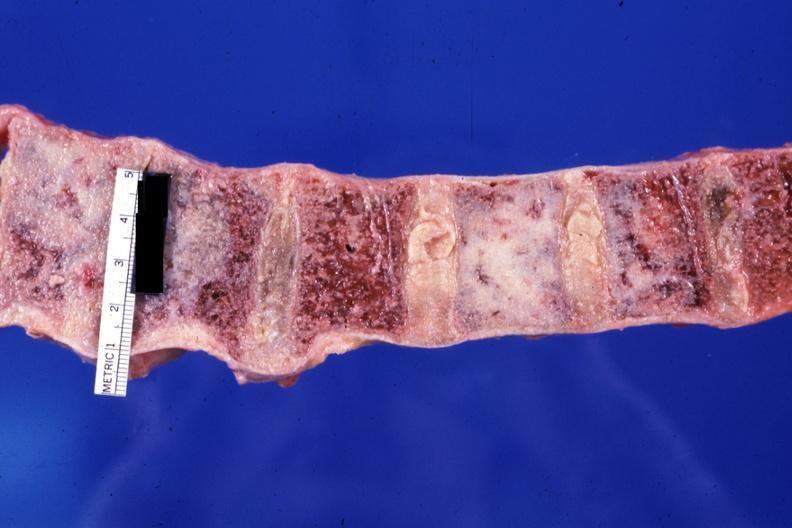what does this image show?
Answer the question using a single word or phrase. Looks like the ivory vertebra with breast carcinoma diagnosis not known at time 